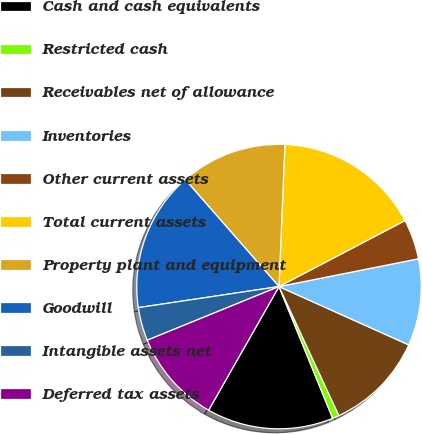<chart> <loc_0><loc_0><loc_500><loc_500><pie_chart><fcel>Cash and cash equivalents<fcel>Restricted cash<fcel>Receivables net of allowance<fcel>Inventories<fcel>Other current assets<fcel>Total current assets<fcel>Property plant and equipment<fcel>Goodwill<fcel>Intangible assets net<fcel>Deferred tax assets<nl><fcel>14.39%<fcel>0.76%<fcel>11.36%<fcel>9.85%<fcel>4.55%<fcel>16.66%<fcel>12.12%<fcel>15.91%<fcel>3.79%<fcel>10.61%<nl></chart> 